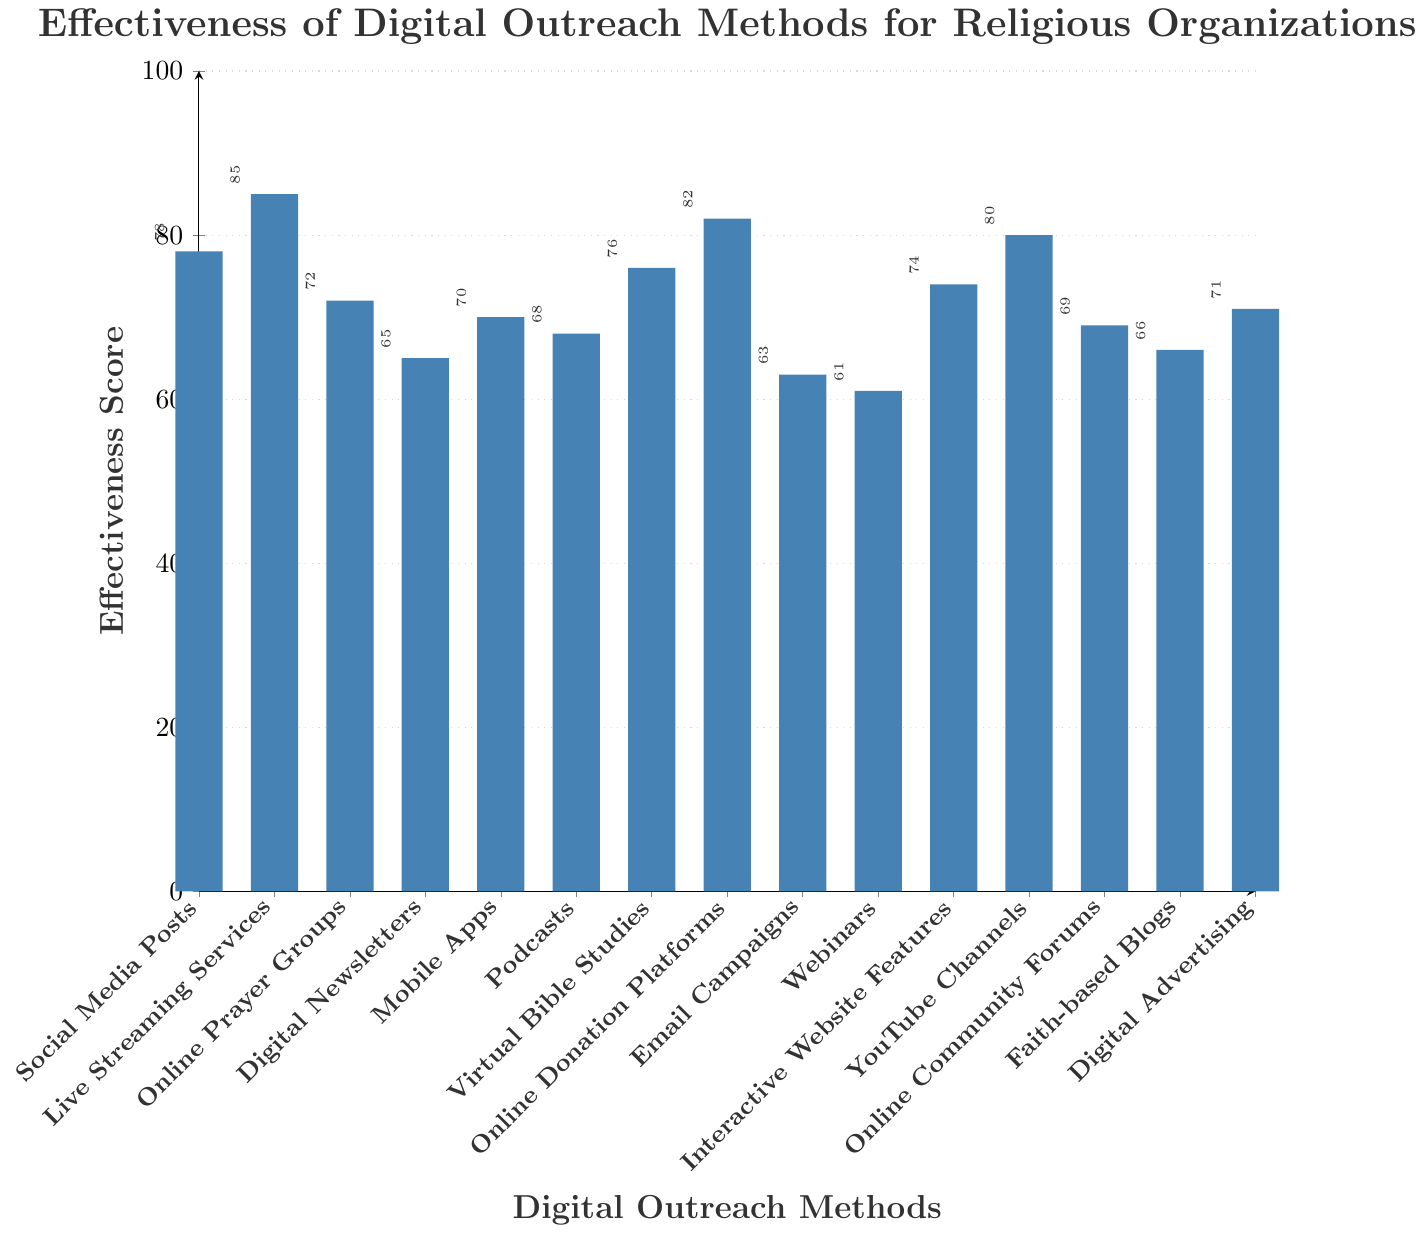Which digital outreach method has the highest effectiveness score? The chart shows the effectiveness scores for various digital outreach methods, and the highest bar corresponds to Live Streaming Services with a score of 85.
Answer: Live Streaming Services What's the average effectiveness score of Social Media Posts, Podcasts, and Digital Advertising? To find the average, first sum their effectiveness scores: (78 + 68 + 71). The sum is 217. Then divide by the number of methods, which is 3. (217 / 3)
Answer: 72.33 Which methods have an effectiveness score above 80? The bars that have heights above 80 correspond to Live Streaming Services (85), Online Donation Platforms (82), and YouTube Channels (80).
Answer: Live Streaming Services, Online Donation Platforms, YouTube Channels What is the effectiveness score difference between Online Prayer Groups and Faith-based Blogs? To determine the difference, subtract the effectiveness score of Faith-based Blogs (66) from that of Online Prayer Groups (72): (72 - 66).
Answer: 6 How does the effectiveness score of Webinars compare to that of Email Campaigns? The effectiveness score of Webinars is 61, while that of Email Campaigns is 63. Comparing these, Webinars has a slightly lower score: 61 < 63.
Answer: Webinars are less effective than Email Campaigns Which method is the least effective? The shortest bar in the chart corresponds to Webinars, which has the lowest effectiveness score of 61.
Answer: Webinars How many digital outreach methods have an effectiveness score below 70? The bars for Digital Newsletters (65), Email Campaigns (63), Webinars (61), Faith-based Blogs (66), Podcasts (68), and Online Community Forums (69) are all below 70. Count these methods: (6).
Answer: 6 By how much does the effectiveness score of Online Donation Platforms exceed that of Mobile Apps? Subtract the effectiveness score of Mobile Apps (70) from that of Online Donation Platforms (82): (82 - 70).
Answer: 12 Are there more digital outreach methods with effectiveness scores above 75 or below 65? Methods above 75 are: Social Media Posts (78), Live Streaming Services (85), Virtual Bible Studies (76), Online Donation Platforms (82), YouTube Channels (80). Methods below 65 are: Email Campaigns (63), Webinars (61). There are 5 methods above 75 and 2 below 65.
Answer: More above 75 What is the median effectiveness score of all the methods listed? First, list all scores in ascending order: (61, 63, 65, 66, 68, 69, 70, 71, 72, 74, 76, 78, 80, 82, 85). With 15 scores, the median is the 8th value in this ordered list.
Answer: 71 